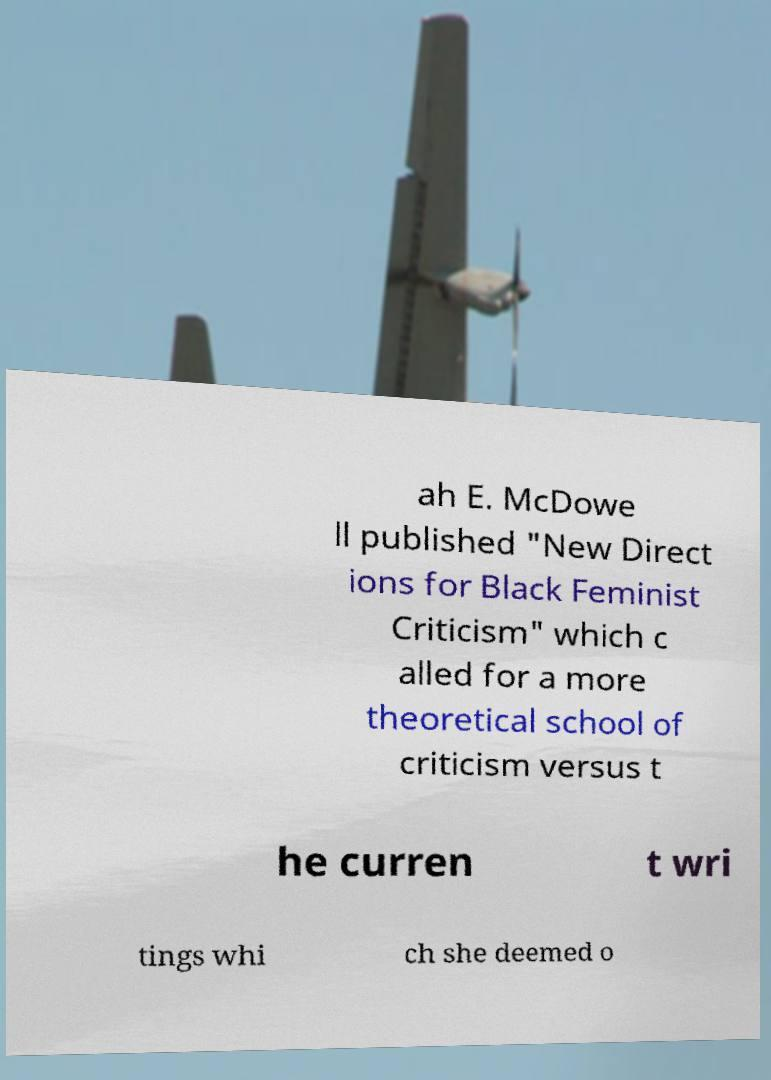Can you read and provide the text displayed in the image?This photo seems to have some interesting text. Can you extract and type it out for me? ah E. McDowe ll published "New Direct ions for Black Feminist Criticism" which c alled for a more theoretical school of criticism versus t he curren t wri tings whi ch she deemed o 